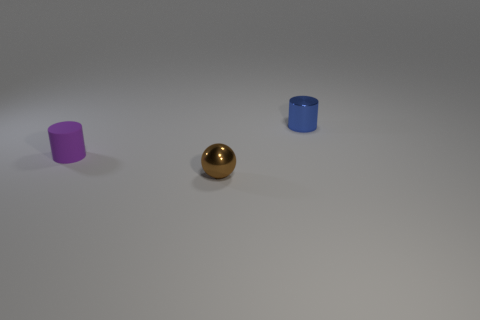What material is the tiny cylinder that is right of the tiny shiny thing in front of the cylinder that is on the left side of the small blue shiny object?
Ensure brevity in your answer.  Metal. What material is the blue object that is the same shape as the purple matte object?
Make the answer very short. Metal. What number of other objects are there of the same size as the brown metal thing?
Offer a terse response. 2. What shape is the tiny shiny thing that is in front of the tiny cylinder that is on the left side of the tiny metal thing behind the tiny brown thing?
Make the answer very short. Sphere. What is the shape of the small thing that is both behind the shiny sphere and to the right of the small purple matte cylinder?
Provide a succinct answer. Cylinder. How many objects are either gray matte cylinders or brown things that are in front of the tiny purple matte thing?
Make the answer very short. 1. Do the tiny brown sphere and the purple cylinder have the same material?
Your answer should be compact. No. What number of other objects are there of the same shape as the small purple matte thing?
Your answer should be compact. 1. There is a object that is to the right of the tiny purple thing and behind the brown metallic sphere; how big is it?
Offer a terse response. Small. What number of rubber objects are tiny brown cylinders or tiny purple objects?
Give a very brief answer. 1. 